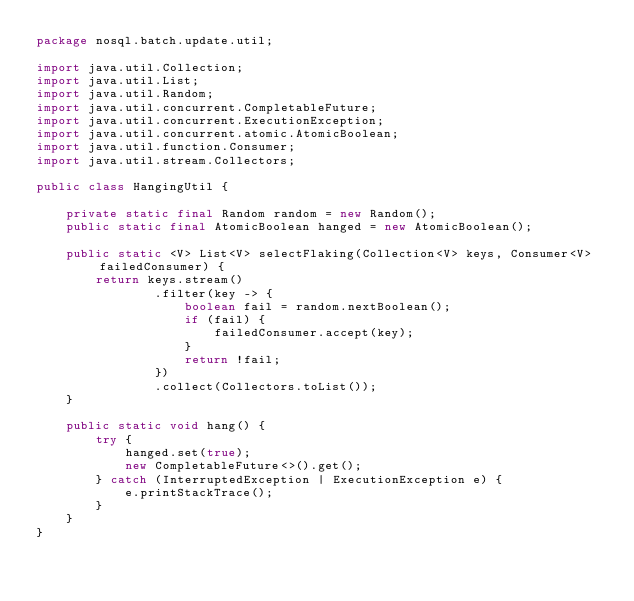<code> <loc_0><loc_0><loc_500><loc_500><_Java_>package nosql.batch.update.util;

import java.util.Collection;
import java.util.List;
import java.util.Random;
import java.util.concurrent.CompletableFuture;
import java.util.concurrent.ExecutionException;
import java.util.concurrent.atomic.AtomicBoolean;
import java.util.function.Consumer;
import java.util.stream.Collectors;

public class HangingUtil {

    private static final Random random = new Random();
    public static final AtomicBoolean hanged = new AtomicBoolean();

    public static <V> List<V> selectFlaking(Collection<V> keys, Consumer<V> failedConsumer) {
        return keys.stream()
                .filter(key -> {
                    boolean fail = random.nextBoolean();
                    if (fail) {
                        failedConsumer.accept(key);
                    }
                    return !fail;
                })
                .collect(Collectors.toList());
    }

    public static void hang() {
        try {
            hanged.set(true);
            new CompletableFuture<>().get();
        } catch (InterruptedException | ExecutionException e) {
            e.printStackTrace();
        }
    }
}
</code> 